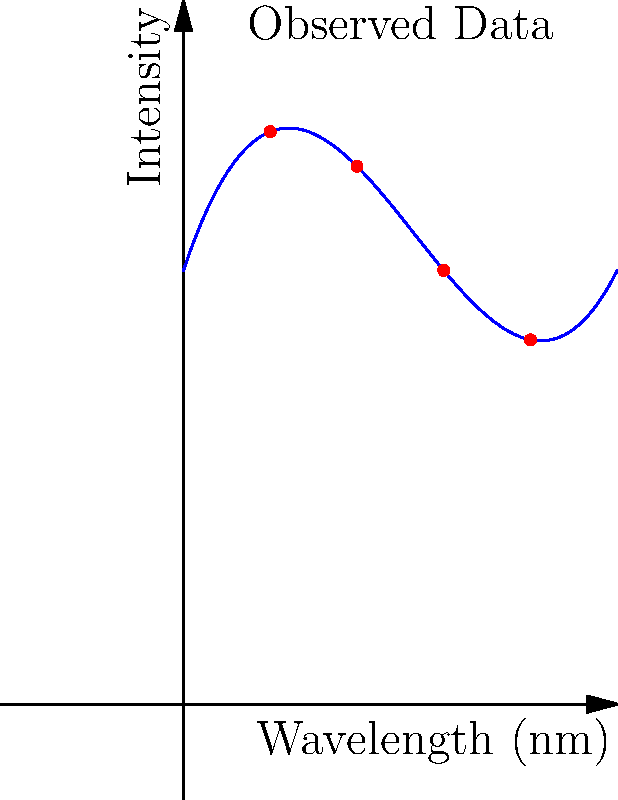As a director of photography specializing in cosmic visuals, you're analyzing the spectral data of a newly discovered exoplanet. The graph shows the relationship between wavelength and intensity of light reflected from the planet's atmosphere. Which degree polynomial would best fit this data for accurate analysis? To determine the best polynomial degree for this data, we need to analyze the curve's shape and complexity:

1. The curve is not linear, ruling out a 1st-degree polynomial.
2. It's not a simple parabola, so a 2nd-degree polynomial is insufficient.
3. The curve has one clear inflection point, changing from concave down to concave up.
4. There are no additional oscillations or complex features.

Given these observations:

- A 3rd-degree polynomial (cubic) would be the most appropriate choice. It can capture the single inflection point and the overall shape of the curve.
- Higher degree polynomials (4th or above) would be unnecessary and might lead to overfitting.

The general form of a 3rd-degree polynomial is:

$$ f(x) = ax^3 + bx^2 + cx + d $$

This form can accurately model the observed spectral data, capturing the essential features without introducing unnecessary complexity.
Answer: 3rd-degree polynomial 